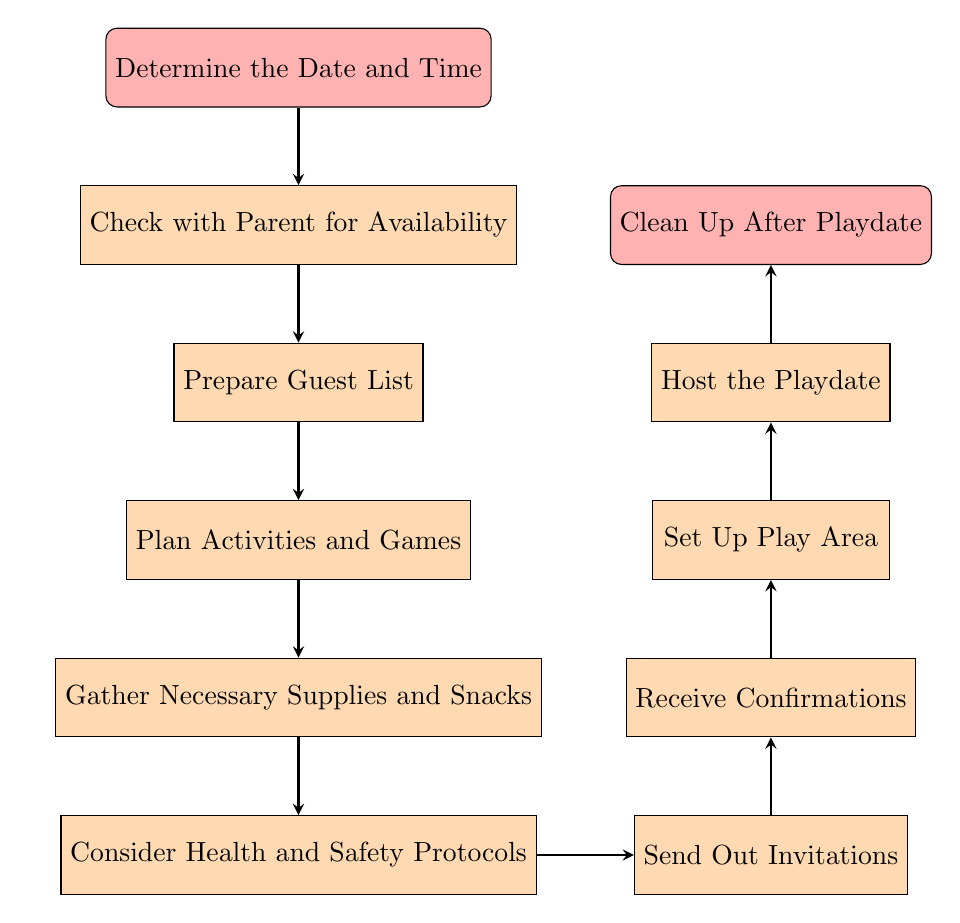What is the first step in organizing a playdate? The first step, as indicated in the diagram, is "Determine the Date and Time". This is the starting point, and the flowchart begins with this action.
Answer: Determine the Date and Time How many total steps are there in the playdate organization process? By counting each distinct node in the diagram, we find there are 11 total steps, ranging from starting to cleaning up after the playdate.
Answer: 11 What follows after preparing the guest list? According to the flowchart, the next step after "Prepare Guest List" is "Plan Activities and Games". This indicates a sequence where activities are planned based on the guest list.
Answer: Plan Activities and Games Which node comes before sending out invitations? The node that comes before "Send Out Invitations" is "Consider Health and Safety Protocols", indicating that invitations should only be sent after ensuring health and safety measures are in place.
Answer: Consider Health and Safety Protocols What is the last step of the playdate organization process? The last step specified in the diagram is "Clean Up After Playdate", as it concludes the entire process of organizing a playdate.
Answer: Clean Up After Playdate If the guest list is not prepared, which step cannot occur? "Plan Activities and Games" cannot take place without the completion of "Prepare Guest List", as it is a prerequisite for planning activities.
Answer: Plan Activities and Games How many steps are there between planning activities and cleaning up? There are 5 steps in total between "Plan Activities and Games" and "Clean Up After Playdate": Gather Necessary Supplies and Snacks, Consider Health and Safety Protocols, Send Out Invitations, Receive Confirmations, and Set Up Play Area.
Answer: 5 What is the relationship between confirming attendance and setting up the play area? The relationship is sequential; "Receive Confirmations" must occur before "Set Up Play Area", meaning you must confirm attendance before you can prepare the play area.
Answer: Receive Confirmations What step directly follows checking with the parent for availability? Directly following "Check with Parent for Availability" is "Prepare Guest List", indicating that the next action depends on confirming availability.
Answer: Prepare Guest List 